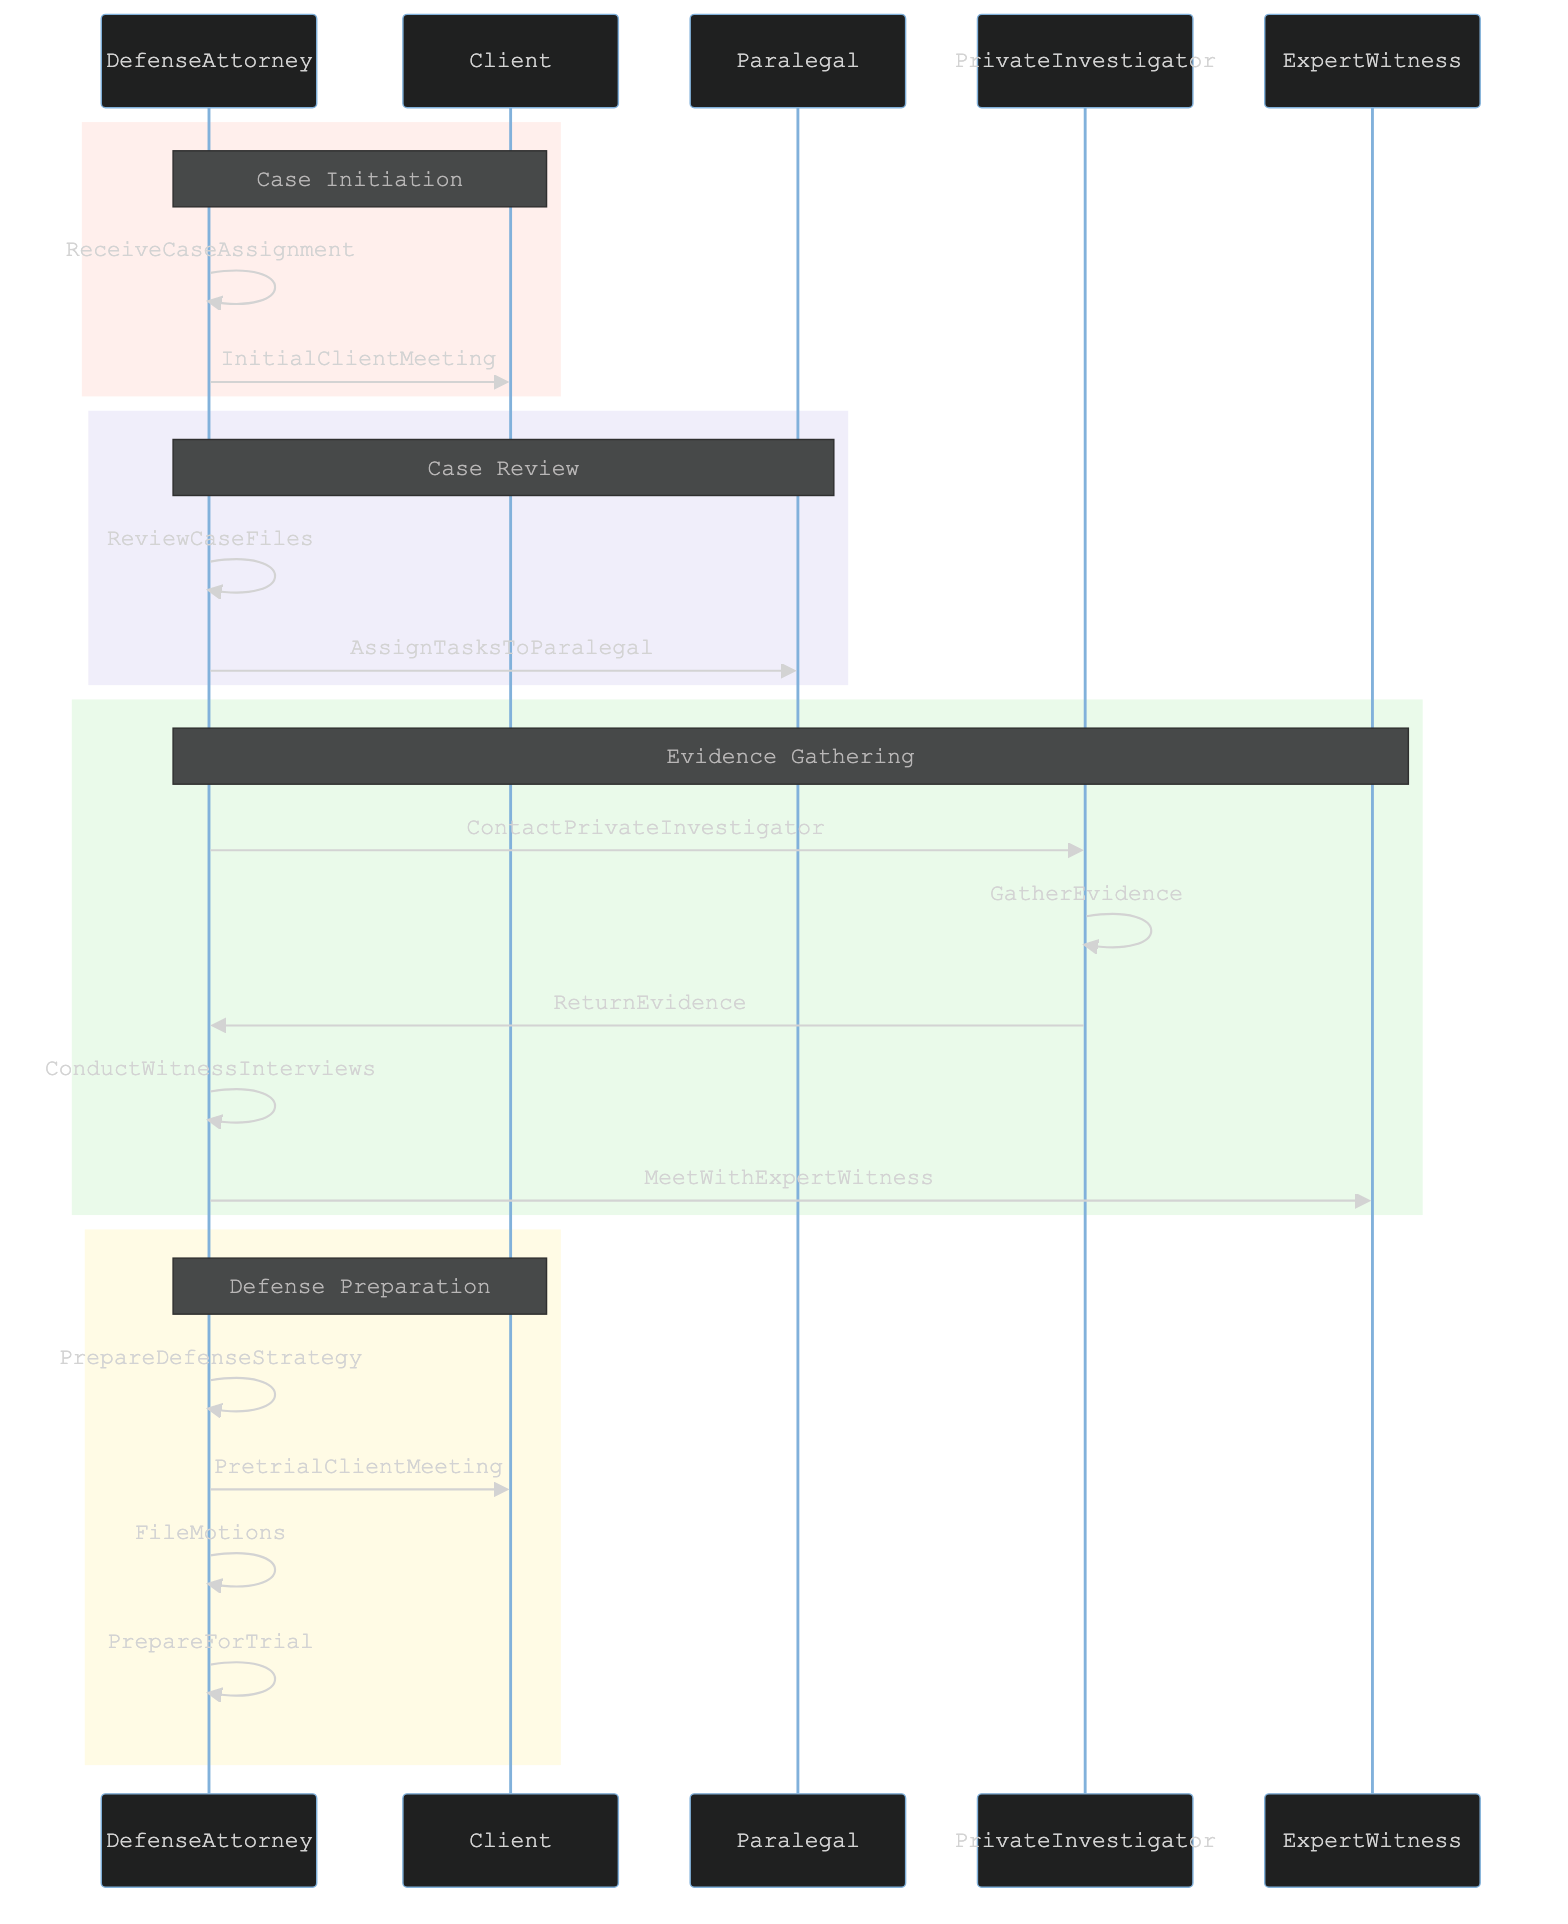What is the first action taken by the Defense Attorney? The diagram shows that the first action performed by the Defense Attorney is "ReceiveCaseAssignment," which is represented as the first line of interaction in the Case Initiation section.
Answer: ReceiveCaseAssignment How many actors are involved in this process? By counting the participants listed at the top of the diagram, there are five actors involved: DefenseAttorney, Client, Paralegal, PrivateInvestigator, and ExpertWitness.
Answer: Five Which action follows the "InitialClientMeeting"? The sequence diagram illustrates that after "InitialClientMeeting," the next action performed by the Defense Attorney is "ReviewCaseFiles," shown directly after in the Case Initiation section.
Answer: ReviewCaseFiles Who is responsible for gathering evidence? The diagram indicates that the responsibility of gathering evidence falls to the Private Investigator, as evidenced by the action "GatherEvidence" being initiated by the Private Investigator after the Defense Attorney contacts them.
Answer: PrivateInvestigator How many total actions are shown in the "Defense Preparation" section? In the Defense Preparation section, there are four actions indicated: "PrepareDefenseStrategy," "PretrialClientMeeting," "FileMotions," and "PrepareForTrial." This can be seen by counting the actions in that rectangle.
Answer: Four What action occurs immediately after assigning tasks to the Paralegal? After "AssignTasksToParalegal," the next action the Defense Attorney takes is "ContactPrivateInvestigator," which is visible in the subsequent section of the diagram titled Evidence Gathering.
Answer: ContactPrivateInvestigator What is the final action in the overall process? According to the sequence diagram, the final action listed is "PrepareForTrial," which takes place in the Defense Preparation section and is the last action before the end of the diagram.
Answer: PrepareForTrial Who does the Defense Attorney meet with after conducting witness interviews? The Defense Attorney meets with the Expert Witness as the next action after conducting the witness interviews. This is shown as a direct progression from the action "ConductWitnessInterviews" to "MeetWithExpertWitness."
Answer: ExpertWitness What section does the "ContactPrivateInvestigator" action belong to? This action is part of the "Evidence Gathering" section, as identified by the rectangle containing this action that follows the Case Review section.
Answer: Evidence Gathering 